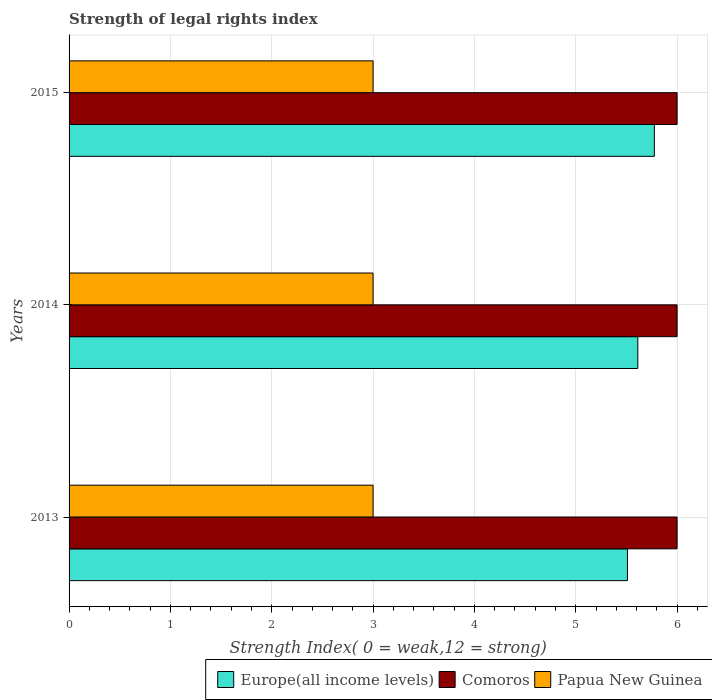How many different coloured bars are there?
Make the answer very short. 3. What is the label of the 2nd group of bars from the top?
Your answer should be very brief. 2014. What is the strength index in Papua New Guinea in 2013?
Your response must be concise. 3. Across all years, what is the maximum strength index in Comoros?
Offer a very short reply. 6. Across all years, what is the minimum strength index in Comoros?
Provide a short and direct response. 6. In which year was the strength index in Europe(all income levels) maximum?
Provide a succinct answer. 2015. What is the total strength index in Europe(all income levels) in the graph?
Provide a succinct answer. 16.9. What is the difference between the strength index in Europe(all income levels) in 2014 and that in 2015?
Provide a succinct answer. -0.16. What is the difference between the strength index in Comoros in 2014 and the strength index in Europe(all income levels) in 2013?
Provide a short and direct response. 0.49. What is the average strength index in Papua New Guinea per year?
Your response must be concise. 3. In the year 2013, what is the difference between the strength index in Europe(all income levels) and strength index in Comoros?
Keep it short and to the point. -0.49. What is the ratio of the strength index in Comoros in 2014 to that in 2015?
Give a very brief answer. 1. Is the strength index in Papua New Guinea in 2014 less than that in 2015?
Offer a very short reply. No. What is the difference between the highest and the second highest strength index in Comoros?
Keep it short and to the point. 0. What is the difference between the highest and the lowest strength index in Papua New Guinea?
Give a very brief answer. 0. In how many years, is the strength index in Europe(all income levels) greater than the average strength index in Europe(all income levels) taken over all years?
Offer a very short reply. 1. Is the sum of the strength index in Europe(all income levels) in 2013 and 2014 greater than the maximum strength index in Comoros across all years?
Provide a succinct answer. Yes. What does the 1st bar from the top in 2013 represents?
Your response must be concise. Papua New Guinea. What does the 3rd bar from the bottom in 2013 represents?
Provide a short and direct response. Papua New Guinea. How many bars are there?
Ensure brevity in your answer.  9. Are the values on the major ticks of X-axis written in scientific E-notation?
Keep it short and to the point. No. Does the graph contain any zero values?
Make the answer very short. No. Where does the legend appear in the graph?
Provide a succinct answer. Bottom right. How are the legend labels stacked?
Keep it short and to the point. Horizontal. What is the title of the graph?
Offer a very short reply. Strength of legal rights index. Does "Dominican Republic" appear as one of the legend labels in the graph?
Provide a succinct answer. No. What is the label or title of the X-axis?
Make the answer very short. Strength Index( 0 = weak,12 = strong). What is the Strength Index( 0 = weak,12 = strong) in Europe(all income levels) in 2013?
Ensure brevity in your answer.  5.51. What is the Strength Index( 0 = weak,12 = strong) in Europe(all income levels) in 2014?
Provide a succinct answer. 5.61. What is the Strength Index( 0 = weak,12 = strong) in Comoros in 2014?
Ensure brevity in your answer.  6. What is the Strength Index( 0 = weak,12 = strong) of Europe(all income levels) in 2015?
Your answer should be compact. 5.78. Across all years, what is the maximum Strength Index( 0 = weak,12 = strong) of Europe(all income levels)?
Keep it short and to the point. 5.78. Across all years, what is the maximum Strength Index( 0 = weak,12 = strong) in Papua New Guinea?
Your answer should be very brief. 3. Across all years, what is the minimum Strength Index( 0 = weak,12 = strong) in Europe(all income levels)?
Your answer should be compact. 5.51. Across all years, what is the minimum Strength Index( 0 = weak,12 = strong) of Comoros?
Offer a terse response. 6. Across all years, what is the minimum Strength Index( 0 = weak,12 = strong) of Papua New Guinea?
Give a very brief answer. 3. What is the total Strength Index( 0 = weak,12 = strong) in Europe(all income levels) in the graph?
Ensure brevity in your answer.  16.9. What is the difference between the Strength Index( 0 = weak,12 = strong) of Europe(all income levels) in 2013 and that in 2014?
Keep it short and to the point. -0.1. What is the difference between the Strength Index( 0 = weak,12 = strong) of Comoros in 2013 and that in 2014?
Your answer should be compact. 0. What is the difference between the Strength Index( 0 = weak,12 = strong) of Europe(all income levels) in 2013 and that in 2015?
Offer a terse response. -0.27. What is the difference between the Strength Index( 0 = weak,12 = strong) in Papua New Guinea in 2013 and that in 2015?
Your response must be concise. 0. What is the difference between the Strength Index( 0 = weak,12 = strong) in Europe(all income levels) in 2014 and that in 2015?
Keep it short and to the point. -0.16. What is the difference between the Strength Index( 0 = weak,12 = strong) in Europe(all income levels) in 2013 and the Strength Index( 0 = weak,12 = strong) in Comoros in 2014?
Make the answer very short. -0.49. What is the difference between the Strength Index( 0 = weak,12 = strong) of Europe(all income levels) in 2013 and the Strength Index( 0 = weak,12 = strong) of Papua New Guinea in 2014?
Provide a short and direct response. 2.51. What is the difference between the Strength Index( 0 = weak,12 = strong) of Comoros in 2013 and the Strength Index( 0 = weak,12 = strong) of Papua New Guinea in 2014?
Offer a very short reply. 3. What is the difference between the Strength Index( 0 = weak,12 = strong) of Europe(all income levels) in 2013 and the Strength Index( 0 = weak,12 = strong) of Comoros in 2015?
Ensure brevity in your answer.  -0.49. What is the difference between the Strength Index( 0 = weak,12 = strong) in Europe(all income levels) in 2013 and the Strength Index( 0 = weak,12 = strong) in Papua New Guinea in 2015?
Offer a terse response. 2.51. What is the difference between the Strength Index( 0 = weak,12 = strong) in Comoros in 2013 and the Strength Index( 0 = weak,12 = strong) in Papua New Guinea in 2015?
Provide a short and direct response. 3. What is the difference between the Strength Index( 0 = weak,12 = strong) of Europe(all income levels) in 2014 and the Strength Index( 0 = weak,12 = strong) of Comoros in 2015?
Your answer should be compact. -0.39. What is the difference between the Strength Index( 0 = weak,12 = strong) of Europe(all income levels) in 2014 and the Strength Index( 0 = weak,12 = strong) of Papua New Guinea in 2015?
Your answer should be very brief. 2.61. What is the difference between the Strength Index( 0 = weak,12 = strong) in Comoros in 2014 and the Strength Index( 0 = weak,12 = strong) in Papua New Guinea in 2015?
Give a very brief answer. 3. What is the average Strength Index( 0 = weak,12 = strong) of Europe(all income levels) per year?
Provide a succinct answer. 5.63. What is the average Strength Index( 0 = weak,12 = strong) of Comoros per year?
Your answer should be compact. 6. In the year 2013, what is the difference between the Strength Index( 0 = weak,12 = strong) in Europe(all income levels) and Strength Index( 0 = weak,12 = strong) in Comoros?
Offer a very short reply. -0.49. In the year 2013, what is the difference between the Strength Index( 0 = weak,12 = strong) of Europe(all income levels) and Strength Index( 0 = weak,12 = strong) of Papua New Guinea?
Offer a very short reply. 2.51. In the year 2014, what is the difference between the Strength Index( 0 = weak,12 = strong) of Europe(all income levels) and Strength Index( 0 = weak,12 = strong) of Comoros?
Keep it short and to the point. -0.39. In the year 2014, what is the difference between the Strength Index( 0 = weak,12 = strong) in Europe(all income levels) and Strength Index( 0 = weak,12 = strong) in Papua New Guinea?
Offer a very short reply. 2.61. In the year 2015, what is the difference between the Strength Index( 0 = weak,12 = strong) in Europe(all income levels) and Strength Index( 0 = weak,12 = strong) in Comoros?
Offer a terse response. -0.22. In the year 2015, what is the difference between the Strength Index( 0 = weak,12 = strong) of Europe(all income levels) and Strength Index( 0 = weak,12 = strong) of Papua New Guinea?
Your response must be concise. 2.78. In the year 2015, what is the difference between the Strength Index( 0 = weak,12 = strong) of Comoros and Strength Index( 0 = weak,12 = strong) of Papua New Guinea?
Make the answer very short. 3. What is the ratio of the Strength Index( 0 = weak,12 = strong) of Europe(all income levels) in 2013 to that in 2014?
Provide a succinct answer. 0.98. What is the ratio of the Strength Index( 0 = weak,12 = strong) in Comoros in 2013 to that in 2014?
Offer a terse response. 1. What is the ratio of the Strength Index( 0 = weak,12 = strong) of Europe(all income levels) in 2013 to that in 2015?
Give a very brief answer. 0.95. What is the ratio of the Strength Index( 0 = weak,12 = strong) in Europe(all income levels) in 2014 to that in 2015?
Provide a succinct answer. 0.97. What is the ratio of the Strength Index( 0 = weak,12 = strong) of Comoros in 2014 to that in 2015?
Offer a very short reply. 1. What is the ratio of the Strength Index( 0 = weak,12 = strong) in Papua New Guinea in 2014 to that in 2015?
Ensure brevity in your answer.  1. What is the difference between the highest and the second highest Strength Index( 0 = weak,12 = strong) in Europe(all income levels)?
Ensure brevity in your answer.  0.16. What is the difference between the highest and the second highest Strength Index( 0 = weak,12 = strong) of Comoros?
Offer a terse response. 0. What is the difference between the highest and the second highest Strength Index( 0 = weak,12 = strong) in Papua New Guinea?
Ensure brevity in your answer.  0. What is the difference between the highest and the lowest Strength Index( 0 = weak,12 = strong) in Europe(all income levels)?
Ensure brevity in your answer.  0.27. What is the difference between the highest and the lowest Strength Index( 0 = weak,12 = strong) of Papua New Guinea?
Your response must be concise. 0. 